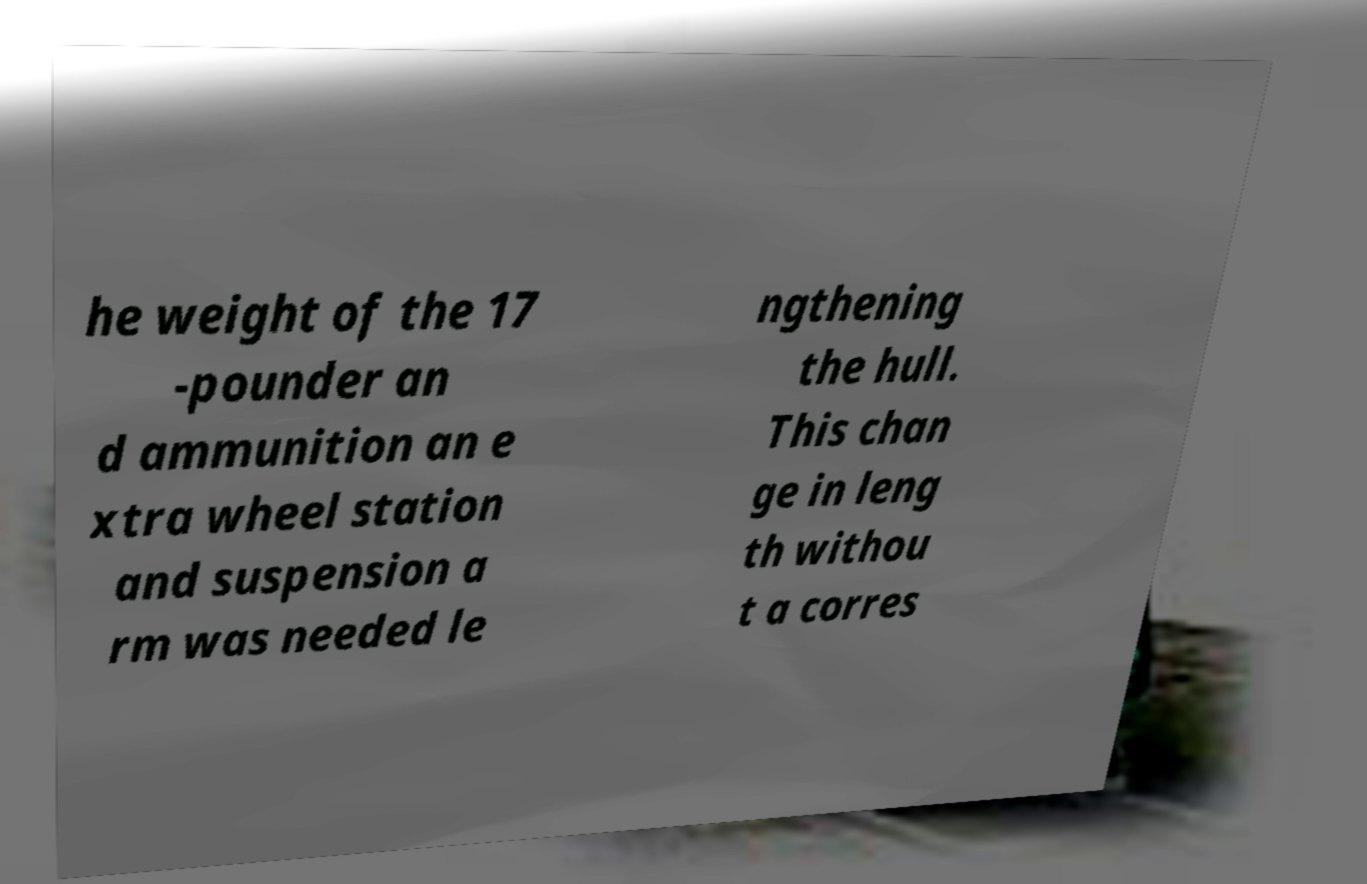Could you assist in decoding the text presented in this image and type it out clearly? he weight of the 17 -pounder an d ammunition an e xtra wheel station and suspension a rm was needed le ngthening the hull. This chan ge in leng th withou t a corres 